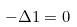Convert formula to latex. <formula><loc_0><loc_0><loc_500><loc_500>- \Delta 1 = 0</formula> 